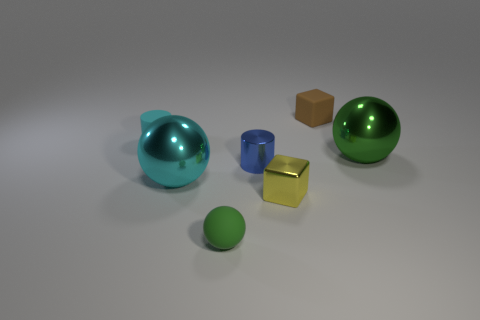Subtract all shiny spheres. How many spheres are left? 1 Add 2 cyan metallic spheres. How many objects exist? 9 Subtract 2 balls. How many balls are left? 1 Subtract all cyan spheres. How many spheres are left? 2 Subtract all spheres. How many objects are left? 4 Add 6 large gray rubber things. How many large gray rubber things exist? 6 Subtract 0 yellow cylinders. How many objects are left? 7 Subtract all yellow cylinders. Subtract all red balls. How many cylinders are left? 2 Subtract all gray balls. How many blue cylinders are left? 1 Subtract all green shiny objects. Subtract all small purple metallic cylinders. How many objects are left? 6 